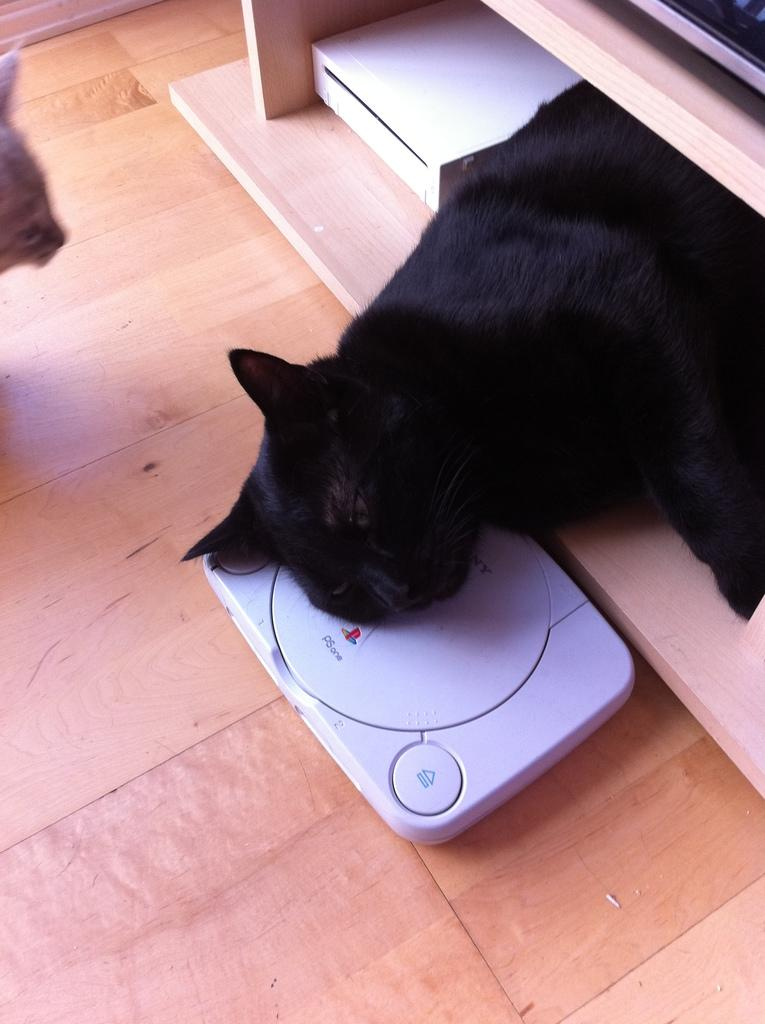What type of animal can be seen in the image? There is a black cat in the image. What is the black cat doing in the image? The black cat is sleeping. Are there any other animals in the image? Yes, there is another cat in the image. What is the second cat doing in the image? The second cat is looking at someone. What else can be seen on the ground in the image? There is a machine on the ground in the image. What type of skin condition does the black cat have in the image? There is no indication of a skin condition on the black cat in the image. What type of cloth is covering the second cat in the image? There is no cloth covering the second cat in the image. 